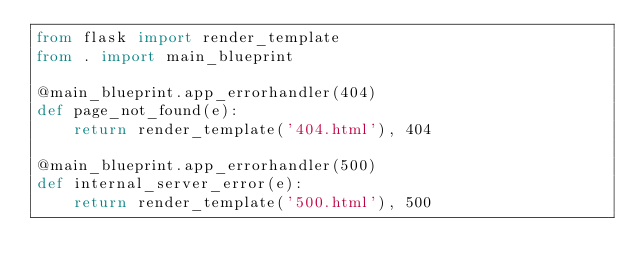Convert code to text. <code><loc_0><loc_0><loc_500><loc_500><_Python_>from flask import render_template
from . import main_blueprint

@main_blueprint.app_errorhandler(404)
def page_not_found(e):
    return render_template('404.html'), 404

@main_blueprint.app_errorhandler(500)
def internal_server_error(e):
    return render_template('500.html'), 500
</code> 